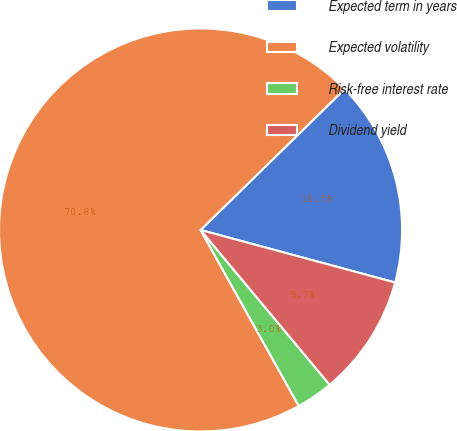<chart> <loc_0><loc_0><loc_500><loc_500><pie_chart><fcel>Expected term in years<fcel>Expected volatility<fcel>Risk-free interest rate<fcel>Dividend yield<nl><fcel>16.52%<fcel>70.78%<fcel>2.96%<fcel>9.74%<nl></chart> 